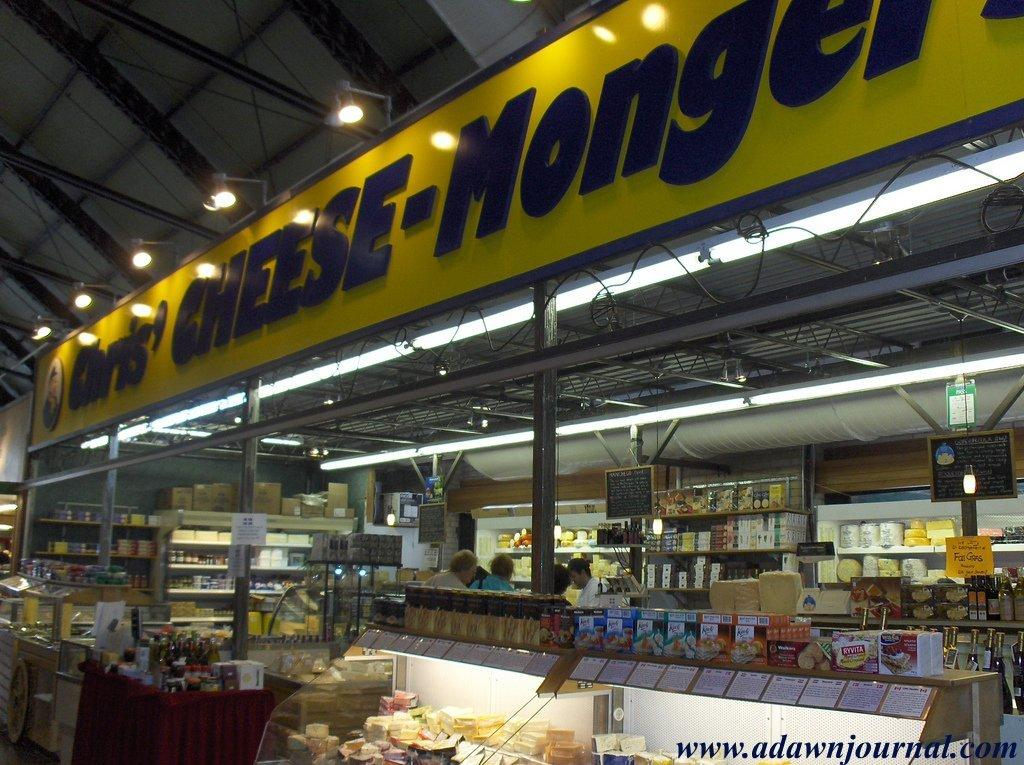<image>
Render a clear and concise summary of the photo. a supermarket cheese selection provided by the website www.adawnjournal.com 